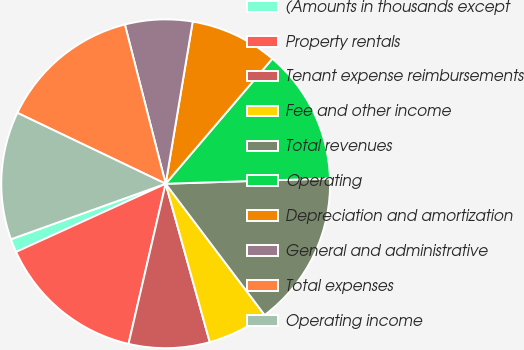<chart> <loc_0><loc_0><loc_500><loc_500><pie_chart><fcel>(Amounts in thousands except<fcel>Property rentals<fcel>Tenant expense reimbursements<fcel>Fee and other income<fcel>Total revenues<fcel>Operating<fcel>Depreciation and amortization<fcel>General and administrative<fcel>Total expenses<fcel>Operating income<nl><fcel>1.32%<fcel>14.57%<fcel>7.95%<fcel>5.96%<fcel>15.23%<fcel>13.25%<fcel>8.61%<fcel>6.62%<fcel>13.91%<fcel>12.58%<nl></chart> 